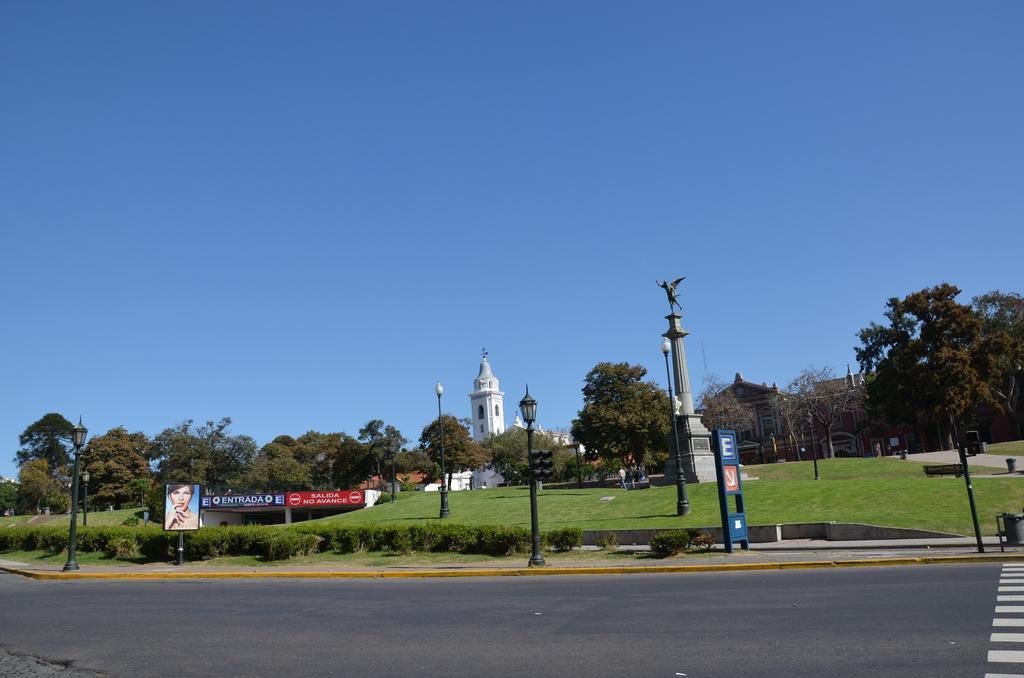Please provide a concise description of this image. In this picture there are buildings and trees and street lights and there are hoardings and there is a statue and there are dustbins on the footpath. At the back there is a person walking. At the top there is sky. At the bottom there is a road and there is grass. 